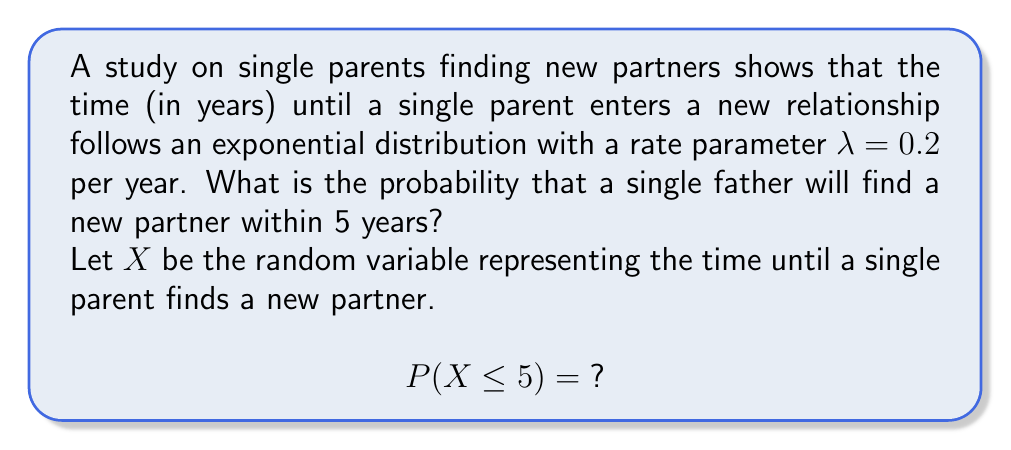Show me your answer to this math problem. To solve this problem, we'll use the cumulative distribution function (CDF) of the exponential distribution:

1) The CDF of an exponential distribution is given by:
   $$F(x) = 1 - e^{-\lambda x}$$
   where $\lambda$ is the rate parameter and $x$ is the time.

2) We're given that $\lambda = 0.2$ and we want to find $P(X \leq 5)$, so we'll substitute these values:
   $$P(X \leq 5) = 1 - e^{-0.2 \cdot 5}$$

3) Simplify the exponent:
   $$P(X \leq 5) = 1 - e^{-1}$$

4) Calculate $e^{-1}$:
   $$P(X \leq 5) = 1 - \frac{1}{e} \approx 1 - 0.3679$$

5) Perform the final subtraction:
   $$P(X \leq 5) \approx 0.6321$$

Therefore, the probability that the single father will find a new partner within 5 years is approximately 0.6321 or 63.21%.
Answer: $0.6321$ or $63.21\%$ 